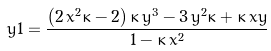<formula> <loc_0><loc_0><loc_500><loc_500>\ y 1 = { \frac { \left ( 2 \, { x } ^ { 2 } \kappa - 2 \right ) \kappa \, { y } ^ { 3 } - 3 \, { y } ^ { 2 } \kappa + \kappa \, x y } { 1 - \kappa \, { x } ^ { 2 } } }</formula> 